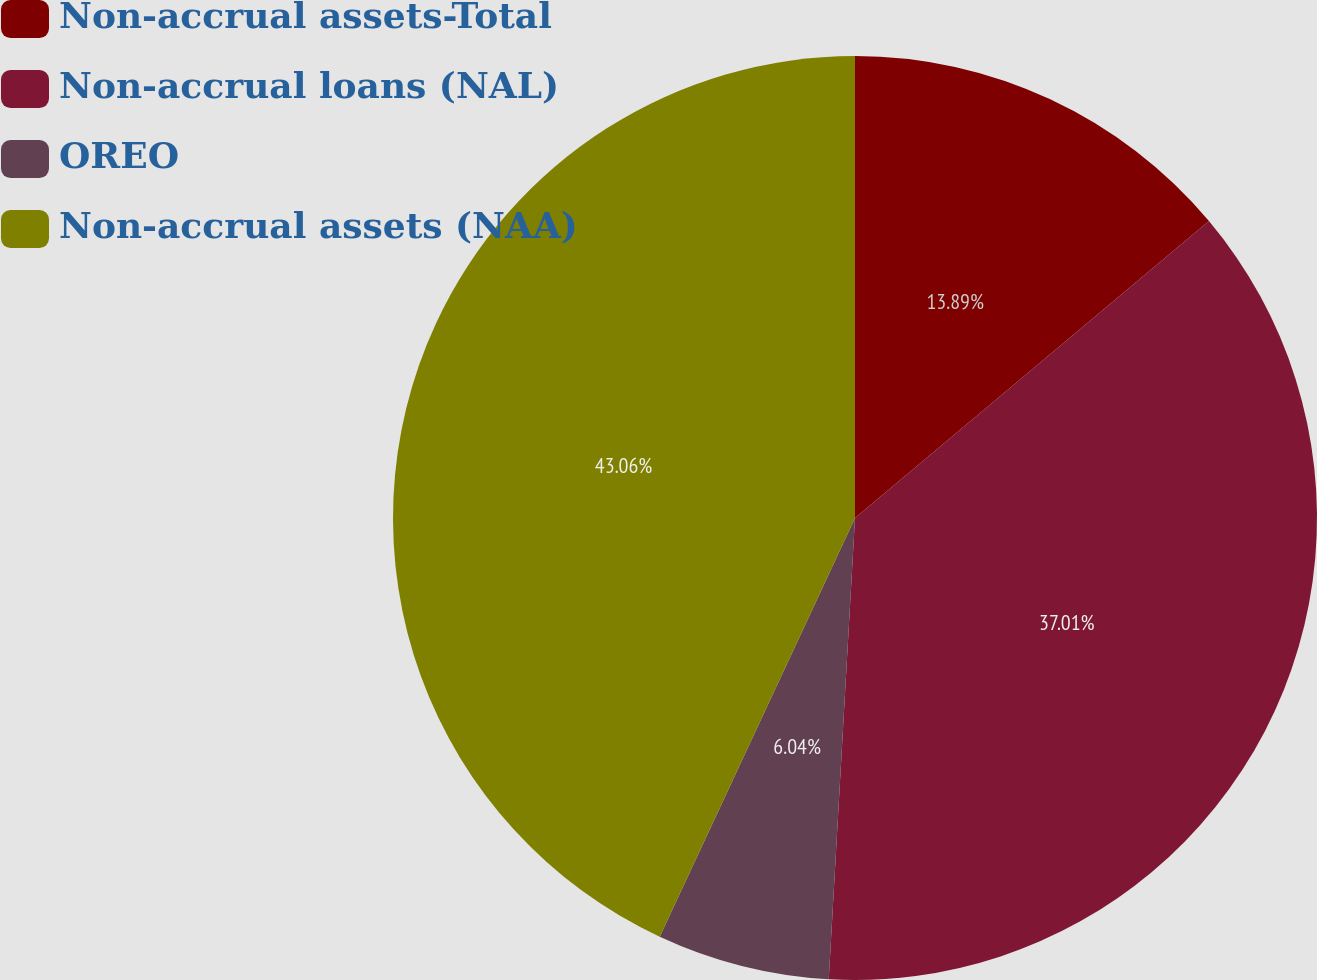Convert chart. <chart><loc_0><loc_0><loc_500><loc_500><pie_chart><fcel>Non-accrual assets-Total<fcel>Non-accrual loans (NAL)<fcel>OREO<fcel>Non-accrual assets (NAA)<nl><fcel>13.89%<fcel>37.01%<fcel>6.04%<fcel>43.05%<nl></chart> 